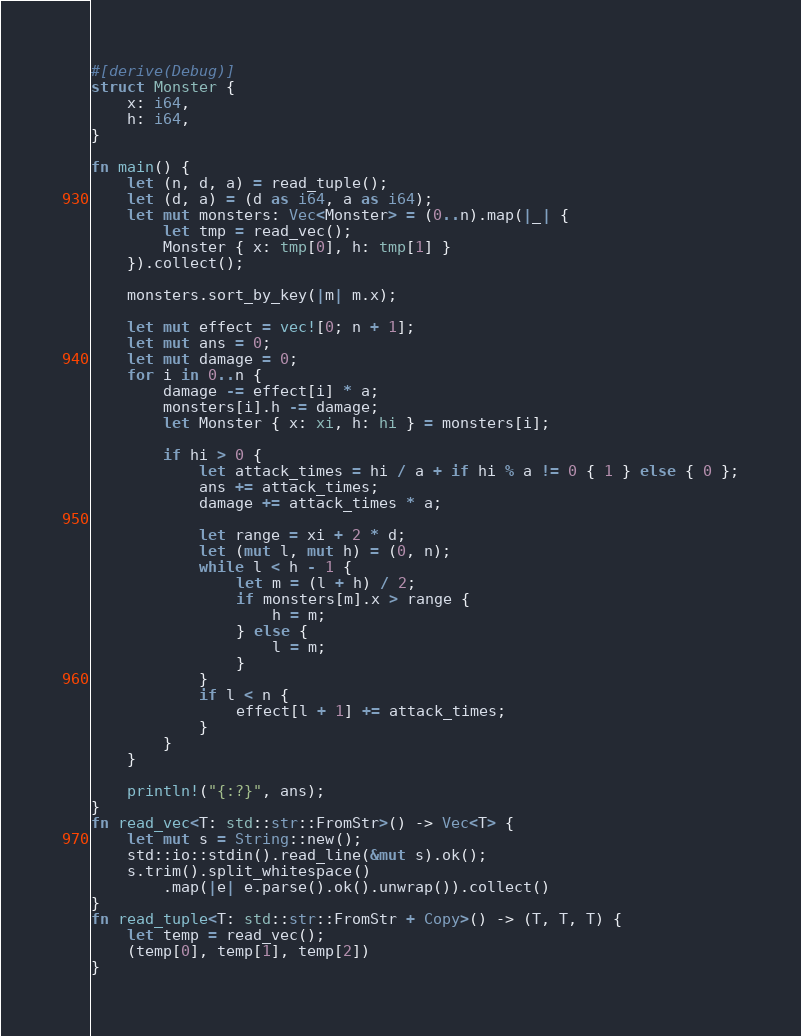<code> <loc_0><loc_0><loc_500><loc_500><_Rust_>#[derive(Debug)]
struct Monster {
    x: i64,
    h: i64,
}

fn main() {
    let (n, d, a) = read_tuple();
    let (d, a) = (d as i64, a as i64);
    let mut monsters: Vec<Monster> = (0..n).map(|_| {
        let tmp = read_vec();
        Monster { x: tmp[0], h: tmp[1] }
    }).collect();

    monsters.sort_by_key(|m| m.x);

    let mut effect = vec![0; n + 1];
    let mut ans = 0;
    let mut damage = 0;
    for i in 0..n {
        damage -= effect[i] * a;
        monsters[i].h -= damage;
        let Monster { x: xi, h: hi } = monsters[i];

        if hi > 0 {
            let attack_times = hi / a + if hi % a != 0 { 1 } else { 0 };
            ans += attack_times;
            damage += attack_times * a;

            let range = xi + 2 * d;
            let (mut l, mut h) = (0, n);
            while l < h - 1 {
                let m = (l + h) / 2;
                if monsters[m].x > range {
                    h = m;
                } else {
                    l = m;
                }
            }
            if l < n {
                effect[l + 1] += attack_times;
            }
        }
    }

    println!("{:?}", ans);
}
fn read_vec<T: std::str::FromStr>() -> Vec<T> {
    let mut s = String::new();
    std::io::stdin().read_line(&mut s).ok();
    s.trim().split_whitespace()
        .map(|e| e.parse().ok().unwrap()).collect()
}
fn read_tuple<T: std::str::FromStr + Copy>() -> (T, T, T) {
    let temp = read_vec();
    (temp[0], temp[1], temp[2])
}

</code> 